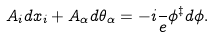<formula> <loc_0><loc_0><loc_500><loc_500>A _ { i } d x _ { i } + A _ { \alpha } d \theta _ { \alpha } = - i \frac { } { e } \phi ^ { \ddagger } d \phi .</formula> 